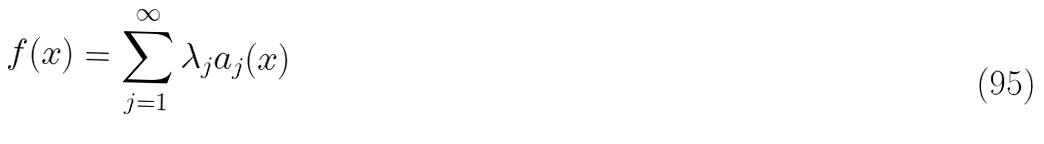<formula> <loc_0><loc_0><loc_500><loc_500>f ( x ) = \sum _ { j = 1 } ^ { \infty } \lambda _ { j } a _ { j } ( x )</formula> 